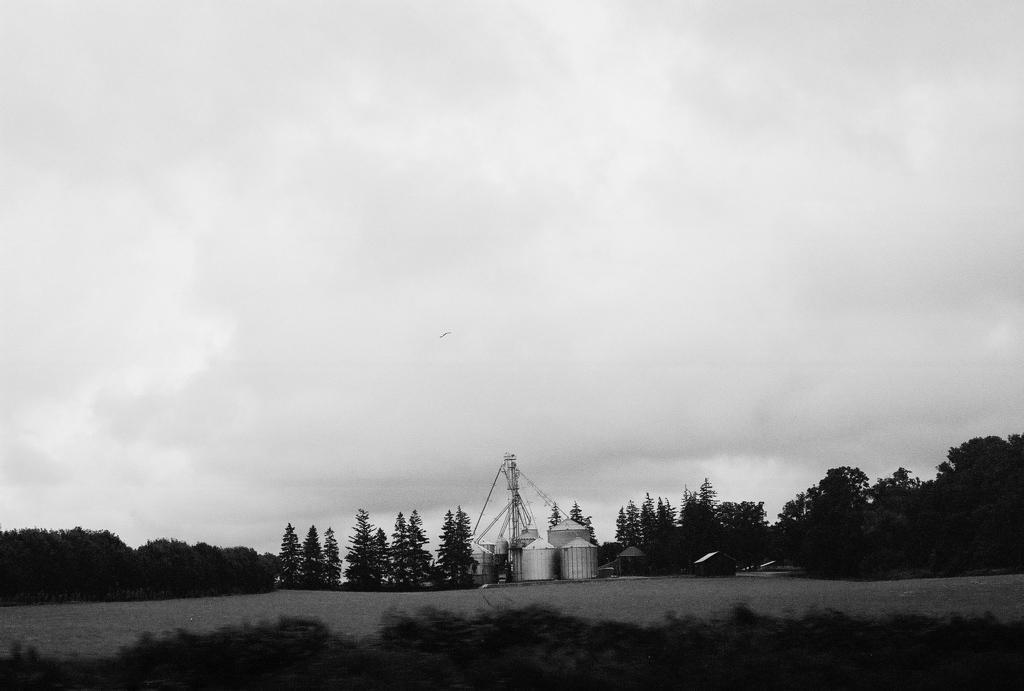Could you give a brief overview of what you see in this image? This is black and white picture, in this picture we can see containers, poles and trees. In the background of the image we can see the sky. At the bottom of the image it is blurry. 